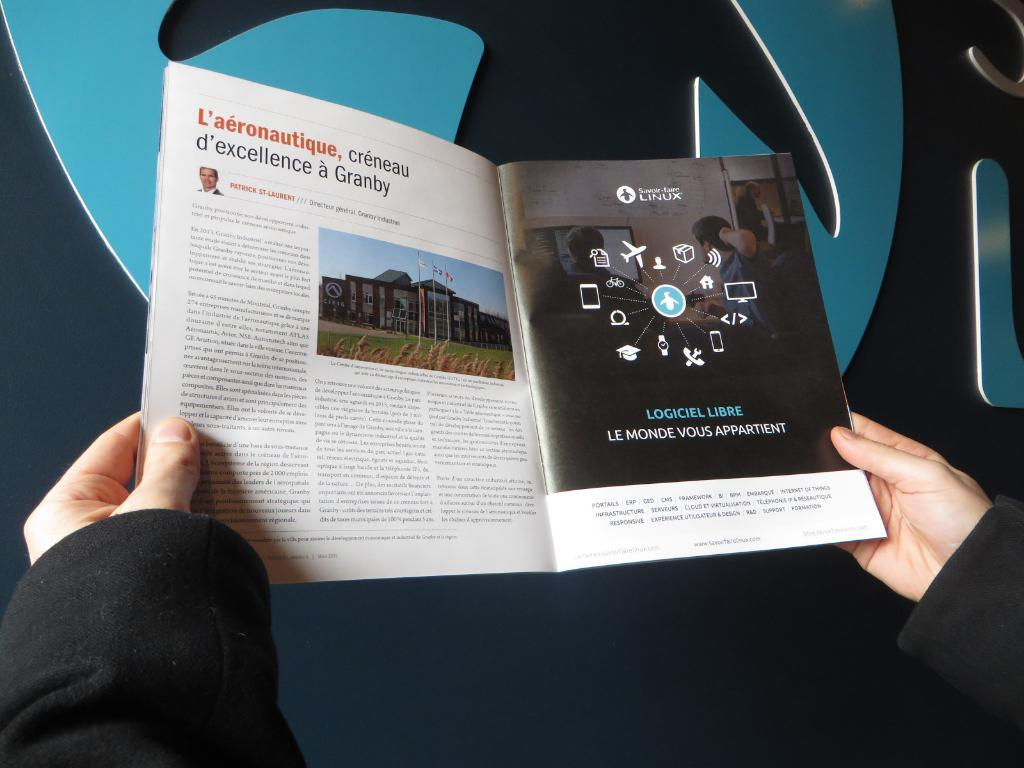Provide a one-sentence caption for the provided image. Man is reading a magazine about Linux Logiciel Libre. 